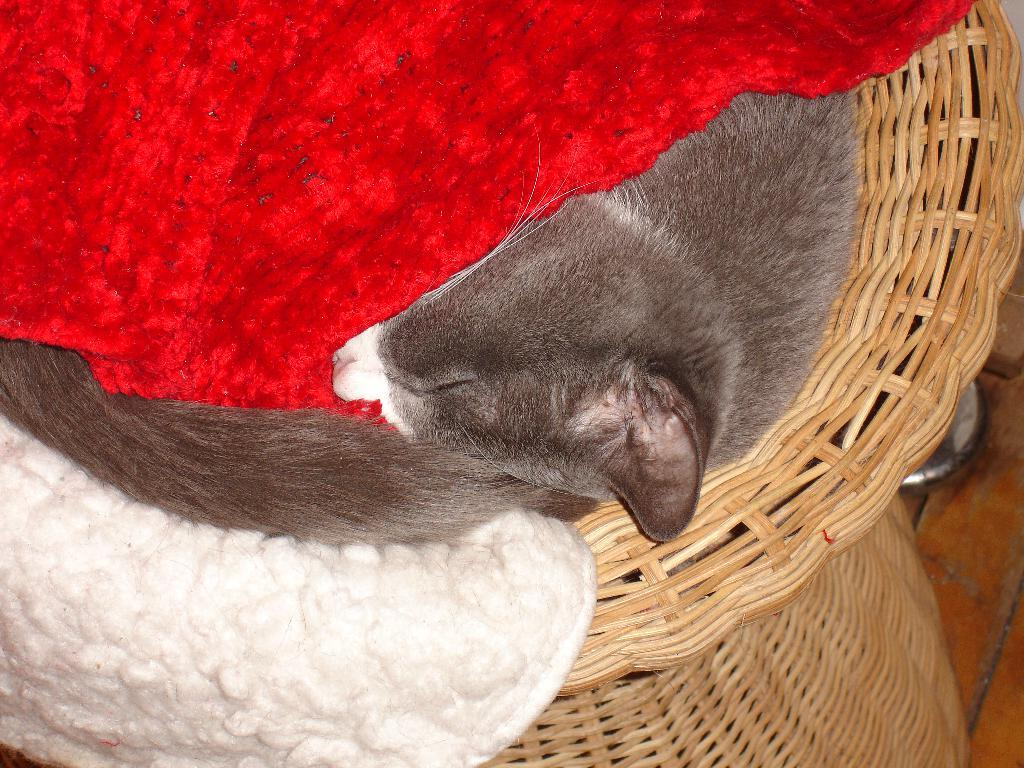What animal can be seen in the image? There is a cat in the image. What is the cat doing in the image? The cat is sleeping in a basket. What type of clothes are visible in the image? There are white and red clothes in the image. What color is the object on the right side of the image? The object on the right side of the image is silver-colored. What type of surface is present in the image? There is a wooden surface in the image. What type of sweater is the government wearing in the image? There is no government or sweater present in the image; it features a cat sleeping in a basket. 